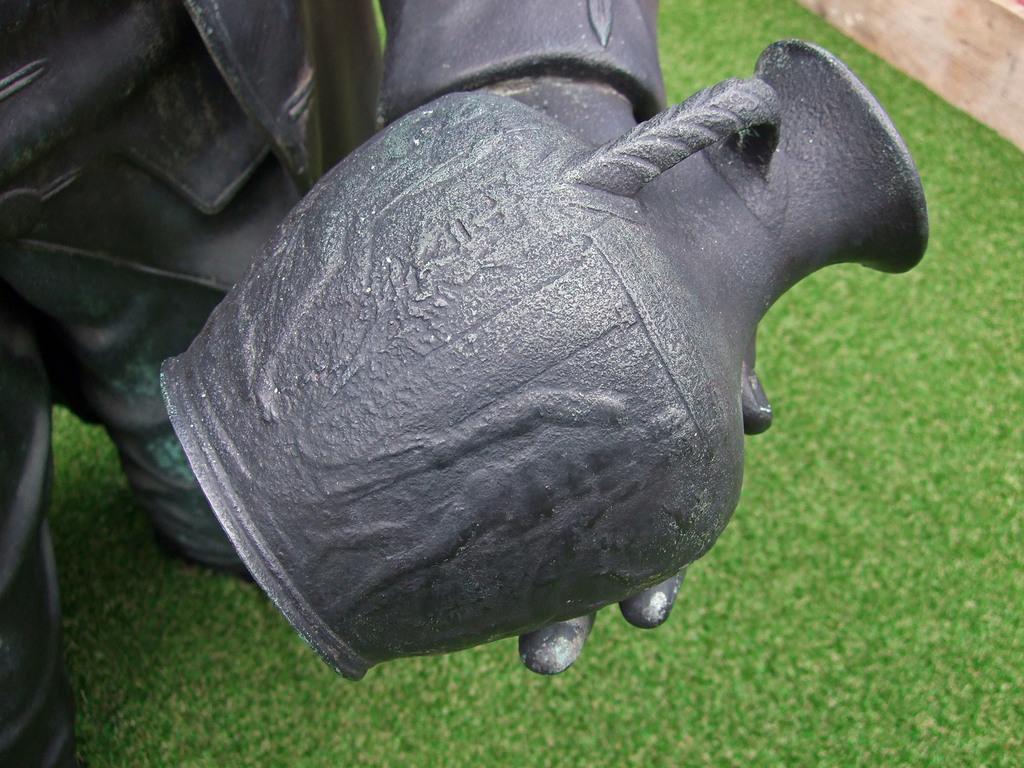Describe this image in one or two sentences. In the center of the image there is a sculpture, which is in black color. In the background there is a wood and grass. 